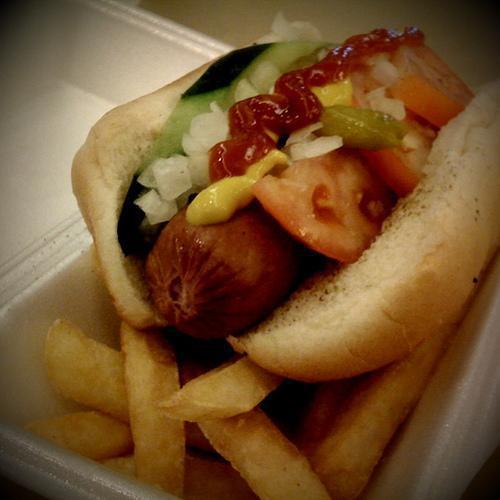How many toppings are on the hot dog?
Give a very brief answer. 6. How many french fries are visible?
Give a very brief answer. 8. How many hot dogs on the plate?
Give a very brief answer. 1. How many pizzas have been half-eaten?
Give a very brief answer. 0. 